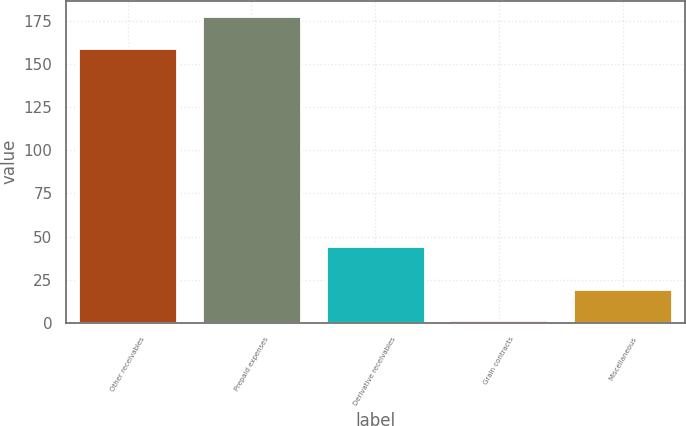Convert chart to OTSL. <chart><loc_0><loc_0><loc_500><loc_500><bar_chart><fcel>Other receivables<fcel>Prepaid expenses<fcel>Derivative receivables<fcel>Grain contracts<fcel>Miscellaneous<nl><fcel>159.3<fcel>177.9<fcel>44.6<fcel>1.8<fcel>19.41<nl></chart> 